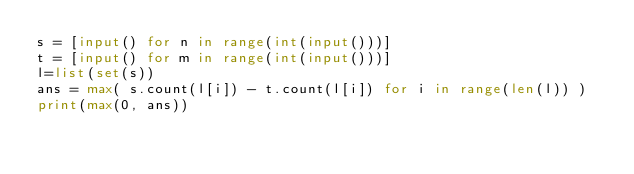<code> <loc_0><loc_0><loc_500><loc_500><_Python_>s = [input() for n in range(int(input()))]
t = [input() for m in range(int(input()))]
l=list(set(s))
ans = max( s.count(l[i]) - t.count(l[i]) for i in range(len(l)) )
print(max(0, ans))</code> 